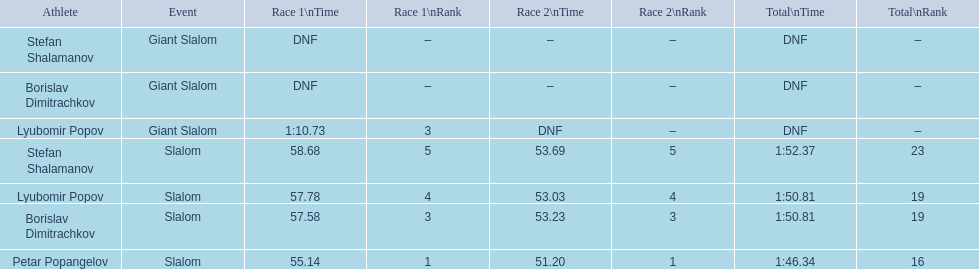What are all the competitions lyubomir popov competed in? Lyubomir Popov, Lyubomir Popov. Of those, which were giant slalom races? Giant Slalom. What was his time in race 1? 1:10.73. 